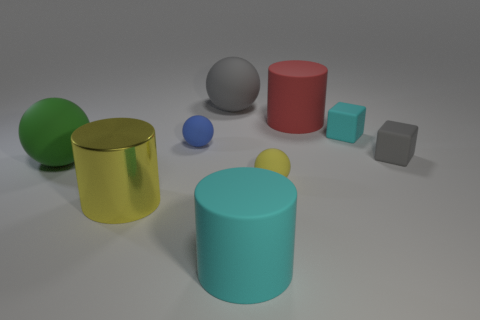Imagine if these objects were part of a game, what could be the rules involving these shapes and colors? In such a game, we could assign different points for stacking objects based on their shape and color. For instance, cylinders might be worth 5 points each, and spheres 10 points. Plus, matching colors could double the score. The objective might be to build the tallest stack without toppling it over within a time limit. 